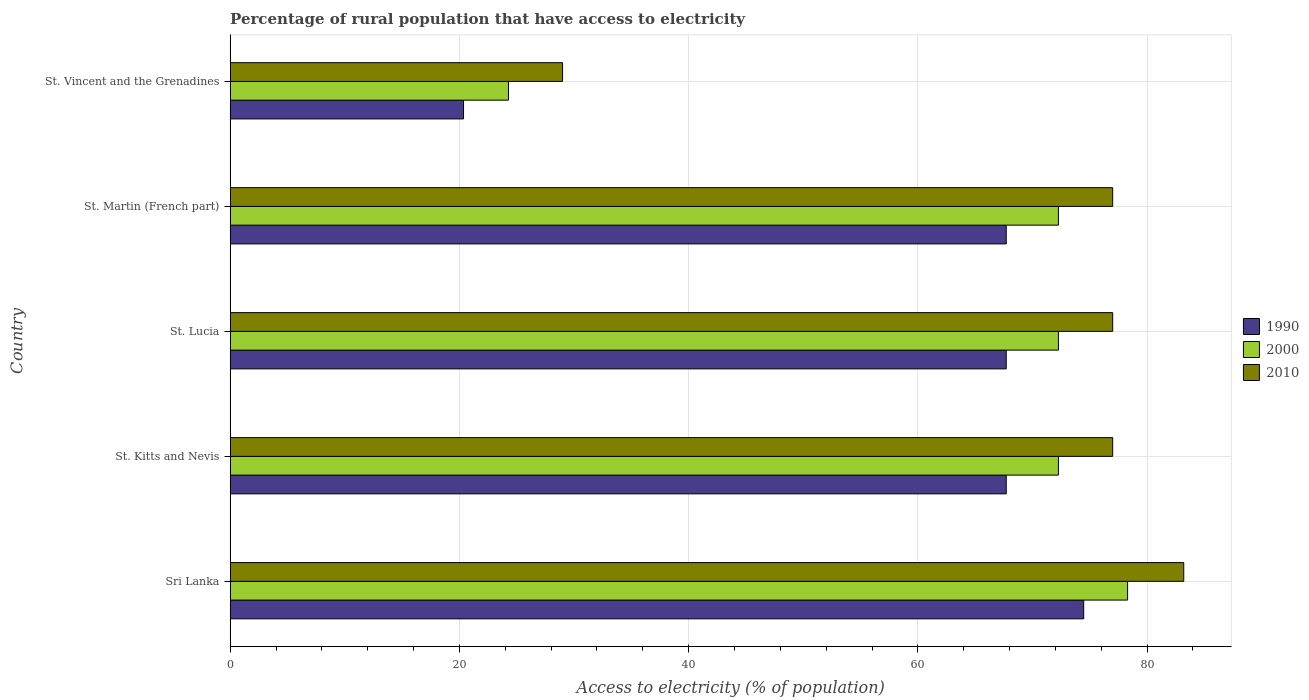How many different coloured bars are there?
Your response must be concise. 3. Are the number of bars on each tick of the Y-axis equal?
Ensure brevity in your answer.  Yes. How many bars are there on the 4th tick from the top?
Offer a very short reply. 3. How many bars are there on the 4th tick from the bottom?
Give a very brief answer. 3. What is the label of the 3rd group of bars from the top?
Your response must be concise. St. Lucia. In how many cases, is the number of bars for a given country not equal to the number of legend labels?
Provide a short and direct response. 0. What is the percentage of rural population that have access to electricity in 1990 in Sri Lanka?
Your answer should be compact. 74.47. Across all countries, what is the maximum percentage of rural population that have access to electricity in 1990?
Give a very brief answer. 74.47. Across all countries, what is the minimum percentage of rural population that have access to electricity in 2010?
Make the answer very short. 29. In which country was the percentage of rural population that have access to electricity in 2000 maximum?
Ensure brevity in your answer.  Sri Lanka. In which country was the percentage of rural population that have access to electricity in 2000 minimum?
Your response must be concise. St. Vincent and the Grenadines. What is the total percentage of rural population that have access to electricity in 1990 in the graph?
Your answer should be compact. 297.96. What is the difference between the percentage of rural population that have access to electricity in 2000 in St. Martin (French part) and the percentage of rural population that have access to electricity in 2010 in St. Kitts and Nevis?
Your answer should be very brief. -4.73. What is the average percentage of rural population that have access to electricity in 2000 per country?
Offer a very short reply. 63.88. What is the difference between the percentage of rural population that have access to electricity in 2010 and percentage of rural population that have access to electricity in 1990 in St. Lucia?
Your answer should be compact. 9.29. What is the ratio of the percentage of rural population that have access to electricity in 1990 in St. Lucia to that in St. Vincent and the Grenadines?
Give a very brief answer. 3.33. Is the percentage of rural population that have access to electricity in 1990 in St. Martin (French part) less than that in St. Vincent and the Grenadines?
Offer a very short reply. No. What is the difference between the highest and the second highest percentage of rural population that have access to electricity in 2010?
Make the answer very short. 6.2. What is the difference between the highest and the lowest percentage of rural population that have access to electricity in 2000?
Provide a short and direct response. 54.02. In how many countries, is the percentage of rural population that have access to electricity in 2000 greater than the average percentage of rural population that have access to electricity in 2000 taken over all countries?
Provide a succinct answer. 4. What does the 1st bar from the bottom in St. Vincent and the Grenadines represents?
Provide a short and direct response. 1990. Is it the case that in every country, the sum of the percentage of rural population that have access to electricity in 1990 and percentage of rural population that have access to electricity in 2000 is greater than the percentage of rural population that have access to electricity in 2010?
Offer a very short reply. Yes. How many bars are there?
Keep it short and to the point. 15. Are all the bars in the graph horizontal?
Provide a short and direct response. Yes. Are the values on the major ticks of X-axis written in scientific E-notation?
Your answer should be compact. No. Does the graph contain any zero values?
Ensure brevity in your answer.  No. Where does the legend appear in the graph?
Offer a very short reply. Center right. How are the legend labels stacked?
Offer a terse response. Vertical. What is the title of the graph?
Your answer should be compact. Percentage of rural population that have access to electricity. Does "1968" appear as one of the legend labels in the graph?
Offer a very short reply. No. What is the label or title of the X-axis?
Provide a succinct answer. Access to electricity (% of population). What is the label or title of the Y-axis?
Your response must be concise. Country. What is the Access to electricity (% of population) of 1990 in Sri Lanka?
Your response must be concise. 74.47. What is the Access to electricity (% of population) of 2000 in Sri Lanka?
Keep it short and to the point. 78.3. What is the Access to electricity (% of population) of 2010 in Sri Lanka?
Your answer should be very brief. 83.2. What is the Access to electricity (% of population) of 1990 in St. Kitts and Nevis?
Ensure brevity in your answer.  67.71. What is the Access to electricity (% of population) in 2000 in St. Kitts and Nevis?
Keep it short and to the point. 72.27. What is the Access to electricity (% of population) in 1990 in St. Lucia?
Your answer should be compact. 67.71. What is the Access to electricity (% of population) of 2000 in St. Lucia?
Offer a very short reply. 72.27. What is the Access to electricity (% of population) of 1990 in St. Martin (French part)?
Offer a very short reply. 67.71. What is the Access to electricity (% of population) in 2000 in St. Martin (French part)?
Make the answer very short. 72.27. What is the Access to electricity (% of population) in 1990 in St. Vincent and the Grenadines?
Your response must be concise. 20.36. What is the Access to electricity (% of population) of 2000 in St. Vincent and the Grenadines?
Your answer should be very brief. 24.28. Across all countries, what is the maximum Access to electricity (% of population) of 1990?
Give a very brief answer. 74.47. Across all countries, what is the maximum Access to electricity (% of population) in 2000?
Your answer should be compact. 78.3. Across all countries, what is the maximum Access to electricity (% of population) in 2010?
Ensure brevity in your answer.  83.2. Across all countries, what is the minimum Access to electricity (% of population) in 1990?
Provide a succinct answer. 20.36. Across all countries, what is the minimum Access to electricity (% of population) in 2000?
Make the answer very short. 24.28. What is the total Access to electricity (% of population) of 1990 in the graph?
Make the answer very short. 297.96. What is the total Access to electricity (% of population) in 2000 in the graph?
Ensure brevity in your answer.  319.38. What is the total Access to electricity (% of population) in 2010 in the graph?
Your response must be concise. 343.2. What is the difference between the Access to electricity (% of population) in 1990 in Sri Lanka and that in St. Kitts and Nevis?
Your answer should be compact. 6.76. What is the difference between the Access to electricity (% of population) in 2000 in Sri Lanka and that in St. Kitts and Nevis?
Provide a short and direct response. 6.04. What is the difference between the Access to electricity (% of population) in 1990 in Sri Lanka and that in St. Lucia?
Provide a short and direct response. 6.76. What is the difference between the Access to electricity (% of population) of 2000 in Sri Lanka and that in St. Lucia?
Provide a short and direct response. 6.04. What is the difference between the Access to electricity (% of population) of 1990 in Sri Lanka and that in St. Martin (French part)?
Make the answer very short. 6.76. What is the difference between the Access to electricity (% of population) in 2000 in Sri Lanka and that in St. Martin (French part)?
Your answer should be compact. 6.04. What is the difference between the Access to electricity (% of population) of 2010 in Sri Lanka and that in St. Martin (French part)?
Keep it short and to the point. 6.2. What is the difference between the Access to electricity (% of population) of 1990 in Sri Lanka and that in St. Vincent and the Grenadines?
Give a very brief answer. 54.11. What is the difference between the Access to electricity (% of population) in 2000 in Sri Lanka and that in St. Vincent and the Grenadines?
Give a very brief answer. 54.02. What is the difference between the Access to electricity (% of population) in 2010 in Sri Lanka and that in St. Vincent and the Grenadines?
Provide a short and direct response. 54.2. What is the difference between the Access to electricity (% of population) of 2000 in St. Kitts and Nevis and that in St. Lucia?
Your answer should be very brief. 0. What is the difference between the Access to electricity (% of population) of 1990 in St. Kitts and Nevis and that in St. Martin (French part)?
Make the answer very short. 0. What is the difference between the Access to electricity (% of population) of 2010 in St. Kitts and Nevis and that in St. Martin (French part)?
Offer a very short reply. 0. What is the difference between the Access to electricity (% of population) in 1990 in St. Kitts and Nevis and that in St. Vincent and the Grenadines?
Make the answer very short. 47.35. What is the difference between the Access to electricity (% of population) of 2000 in St. Kitts and Nevis and that in St. Vincent and the Grenadines?
Ensure brevity in your answer.  47.98. What is the difference between the Access to electricity (% of population) in 2000 in St. Lucia and that in St. Martin (French part)?
Provide a succinct answer. 0. What is the difference between the Access to electricity (% of population) of 2010 in St. Lucia and that in St. Martin (French part)?
Keep it short and to the point. 0. What is the difference between the Access to electricity (% of population) in 1990 in St. Lucia and that in St. Vincent and the Grenadines?
Ensure brevity in your answer.  47.35. What is the difference between the Access to electricity (% of population) of 2000 in St. Lucia and that in St. Vincent and the Grenadines?
Give a very brief answer. 47.98. What is the difference between the Access to electricity (% of population) of 1990 in St. Martin (French part) and that in St. Vincent and the Grenadines?
Give a very brief answer. 47.35. What is the difference between the Access to electricity (% of population) in 2000 in St. Martin (French part) and that in St. Vincent and the Grenadines?
Your answer should be very brief. 47.98. What is the difference between the Access to electricity (% of population) in 1990 in Sri Lanka and the Access to electricity (% of population) in 2000 in St. Kitts and Nevis?
Offer a very short reply. 2.2. What is the difference between the Access to electricity (% of population) in 1990 in Sri Lanka and the Access to electricity (% of population) in 2010 in St. Kitts and Nevis?
Your response must be concise. -2.53. What is the difference between the Access to electricity (% of population) in 2000 in Sri Lanka and the Access to electricity (% of population) in 2010 in St. Kitts and Nevis?
Your answer should be compact. 1.3. What is the difference between the Access to electricity (% of population) of 1990 in Sri Lanka and the Access to electricity (% of population) of 2000 in St. Lucia?
Provide a succinct answer. 2.2. What is the difference between the Access to electricity (% of population) of 1990 in Sri Lanka and the Access to electricity (% of population) of 2010 in St. Lucia?
Your response must be concise. -2.53. What is the difference between the Access to electricity (% of population) in 2000 in Sri Lanka and the Access to electricity (% of population) in 2010 in St. Lucia?
Offer a terse response. 1.3. What is the difference between the Access to electricity (% of population) in 1990 in Sri Lanka and the Access to electricity (% of population) in 2000 in St. Martin (French part)?
Give a very brief answer. 2.2. What is the difference between the Access to electricity (% of population) of 1990 in Sri Lanka and the Access to electricity (% of population) of 2010 in St. Martin (French part)?
Your response must be concise. -2.53. What is the difference between the Access to electricity (% of population) in 1990 in Sri Lanka and the Access to electricity (% of population) in 2000 in St. Vincent and the Grenadines?
Make the answer very short. 50.19. What is the difference between the Access to electricity (% of population) of 1990 in Sri Lanka and the Access to electricity (% of population) of 2010 in St. Vincent and the Grenadines?
Your answer should be compact. 45.47. What is the difference between the Access to electricity (% of population) in 2000 in Sri Lanka and the Access to electricity (% of population) in 2010 in St. Vincent and the Grenadines?
Offer a very short reply. 49.3. What is the difference between the Access to electricity (% of population) in 1990 in St. Kitts and Nevis and the Access to electricity (% of population) in 2000 in St. Lucia?
Your answer should be compact. -4.55. What is the difference between the Access to electricity (% of population) of 1990 in St. Kitts and Nevis and the Access to electricity (% of population) of 2010 in St. Lucia?
Provide a short and direct response. -9.29. What is the difference between the Access to electricity (% of population) of 2000 in St. Kitts and Nevis and the Access to electricity (% of population) of 2010 in St. Lucia?
Provide a succinct answer. -4.74. What is the difference between the Access to electricity (% of population) of 1990 in St. Kitts and Nevis and the Access to electricity (% of population) of 2000 in St. Martin (French part)?
Provide a short and direct response. -4.55. What is the difference between the Access to electricity (% of population) in 1990 in St. Kitts and Nevis and the Access to electricity (% of population) in 2010 in St. Martin (French part)?
Give a very brief answer. -9.29. What is the difference between the Access to electricity (% of population) in 2000 in St. Kitts and Nevis and the Access to electricity (% of population) in 2010 in St. Martin (French part)?
Make the answer very short. -4.74. What is the difference between the Access to electricity (% of population) of 1990 in St. Kitts and Nevis and the Access to electricity (% of population) of 2000 in St. Vincent and the Grenadines?
Your response must be concise. 43.43. What is the difference between the Access to electricity (% of population) in 1990 in St. Kitts and Nevis and the Access to electricity (% of population) in 2010 in St. Vincent and the Grenadines?
Provide a succinct answer. 38.71. What is the difference between the Access to electricity (% of population) of 2000 in St. Kitts and Nevis and the Access to electricity (% of population) of 2010 in St. Vincent and the Grenadines?
Your answer should be very brief. 43.27. What is the difference between the Access to electricity (% of population) in 1990 in St. Lucia and the Access to electricity (% of population) in 2000 in St. Martin (French part)?
Keep it short and to the point. -4.55. What is the difference between the Access to electricity (% of population) of 1990 in St. Lucia and the Access to electricity (% of population) of 2010 in St. Martin (French part)?
Make the answer very short. -9.29. What is the difference between the Access to electricity (% of population) in 2000 in St. Lucia and the Access to electricity (% of population) in 2010 in St. Martin (French part)?
Your response must be concise. -4.74. What is the difference between the Access to electricity (% of population) in 1990 in St. Lucia and the Access to electricity (% of population) in 2000 in St. Vincent and the Grenadines?
Your response must be concise. 43.43. What is the difference between the Access to electricity (% of population) in 1990 in St. Lucia and the Access to electricity (% of population) in 2010 in St. Vincent and the Grenadines?
Ensure brevity in your answer.  38.71. What is the difference between the Access to electricity (% of population) in 2000 in St. Lucia and the Access to electricity (% of population) in 2010 in St. Vincent and the Grenadines?
Give a very brief answer. 43.27. What is the difference between the Access to electricity (% of population) in 1990 in St. Martin (French part) and the Access to electricity (% of population) in 2000 in St. Vincent and the Grenadines?
Your answer should be compact. 43.43. What is the difference between the Access to electricity (% of population) in 1990 in St. Martin (French part) and the Access to electricity (% of population) in 2010 in St. Vincent and the Grenadines?
Ensure brevity in your answer.  38.71. What is the difference between the Access to electricity (% of population) of 2000 in St. Martin (French part) and the Access to electricity (% of population) of 2010 in St. Vincent and the Grenadines?
Provide a succinct answer. 43.27. What is the average Access to electricity (% of population) of 1990 per country?
Keep it short and to the point. 59.59. What is the average Access to electricity (% of population) in 2000 per country?
Make the answer very short. 63.88. What is the average Access to electricity (% of population) of 2010 per country?
Your answer should be compact. 68.64. What is the difference between the Access to electricity (% of population) of 1990 and Access to electricity (% of population) of 2000 in Sri Lanka?
Ensure brevity in your answer.  -3.83. What is the difference between the Access to electricity (% of population) in 1990 and Access to electricity (% of population) in 2010 in Sri Lanka?
Keep it short and to the point. -8.73. What is the difference between the Access to electricity (% of population) of 2000 and Access to electricity (% of population) of 2010 in Sri Lanka?
Offer a terse response. -4.9. What is the difference between the Access to electricity (% of population) of 1990 and Access to electricity (% of population) of 2000 in St. Kitts and Nevis?
Offer a terse response. -4.55. What is the difference between the Access to electricity (% of population) in 1990 and Access to electricity (% of population) in 2010 in St. Kitts and Nevis?
Ensure brevity in your answer.  -9.29. What is the difference between the Access to electricity (% of population) of 2000 and Access to electricity (% of population) of 2010 in St. Kitts and Nevis?
Your response must be concise. -4.74. What is the difference between the Access to electricity (% of population) of 1990 and Access to electricity (% of population) of 2000 in St. Lucia?
Your response must be concise. -4.55. What is the difference between the Access to electricity (% of population) in 1990 and Access to electricity (% of population) in 2010 in St. Lucia?
Give a very brief answer. -9.29. What is the difference between the Access to electricity (% of population) of 2000 and Access to electricity (% of population) of 2010 in St. Lucia?
Offer a terse response. -4.74. What is the difference between the Access to electricity (% of population) of 1990 and Access to electricity (% of population) of 2000 in St. Martin (French part)?
Offer a terse response. -4.55. What is the difference between the Access to electricity (% of population) in 1990 and Access to electricity (% of population) in 2010 in St. Martin (French part)?
Give a very brief answer. -9.29. What is the difference between the Access to electricity (% of population) of 2000 and Access to electricity (% of population) of 2010 in St. Martin (French part)?
Your response must be concise. -4.74. What is the difference between the Access to electricity (% of population) of 1990 and Access to electricity (% of population) of 2000 in St. Vincent and the Grenadines?
Give a very brief answer. -3.92. What is the difference between the Access to electricity (% of population) of 1990 and Access to electricity (% of population) of 2010 in St. Vincent and the Grenadines?
Provide a succinct answer. -8.64. What is the difference between the Access to electricity (% of population) in 2000 and Access to electricity (% of population) in 2010 in St. Vincent and the Grenadines?
Offer a very short reply. -4.72. What is the ratio of the Access to electricity (% of population) in 1990 in Sri Lanka to that in St. Kitts and Nevis?
Your answer should be compact. 1.1. What is the ratio of the Access to electricity (% of population) of 2000 in Sri Lanka to that in St. Kitts and Nevis?
Offer a terse response. 1.08. What is the ratio of the Access to electricity (% of population) in 2010 in Sri Lanka to that in St. Kitts and Nevis?
Give a very brief answer. 1.08. What is the ratio of the Access to electricity (% of population) of 1990 in Sri Lanka to that in St. Lucia?
Make the answer very short. 1.1. What is the ratio of the Access to electricity (% of population) of 2000 in Sri Lanka to that in St. Lucia?
Give a very brief answer. 1.08. What is the ratio of the Access to electricity (% of population) of 2010 in Sri Lanka to that in St. Lucia?
Give a very brief answer. 1.08. What is the ratio of the Access to electricity (% of population) in 1990 in Sri Lanka to that in St. Martin (French part)?
Keep it short and to the point. 1.1. What is the ratio of the Access to electricity (% of population) in 2000 in Sri Lanka to that in St. Martin (French part)?
Offer a terse response. 1.08. What is the ratio of the Access to electricity (% of population) in 2010 in Sri Lanka to that in St. Martin (French part)?
Offer a very short reply. 1.08. What is the ratio of the Access to electricity (% of population) of 1990 in Sri Lanka to that in St. Vincent and the Grenadines?
Offer a very short reply. 3.66. What is the ratio of the Access to electricity (% of population) of 2000 in Sri Lanka to that in St. Vincent and the Grenadines?
Your answer should be very brief. 3.22. What is the ratio of the Access to electricity (% of population) in 2010 in Sri Lanka to that in St. Vincent and the Grenadines?
Your answer should be compact. 2.87. What is the ratio of the Access to electricity (% of population) in 1990 in St. Kitts and Nevis to that in St. Lucia?
Provide a short and direct response. 1. What is the ratio of the Access to electricity (% of population) of 2010 in St. Kitts and Nevis to that in St. Lucia?
Ensure brevity in your answer.  1. What is the ratio of the Access to electricity (% of population) of 1990 in St. Kitts and Nevis to that in St. Martin (French part)?
Offer a terse response. 1. What is the ratio of the Access to electricity (% of population) of 2000 in St. Kitts and Nevis to that in St. Martin (French part)?
Keep it short and to the point. 1. What is the ratio of the Access to electricity (% of population) in 1990 in St. Kitts and Nevis to that in St. Vincent and the Grenadines?
Provide a succinct answer. 3.33. What is the ratio of the Access to electricity (% of population) of 2000 in St. Kitts and Nevis to that in St. Vincent and the Grenadines?
Your answer should be very brief. 2.98. What is the ratio of the Access to electricity (% of population) of 2010 in St. Kitts and Nevis to that in St. Vincent and the Grenadines?
Provide a short and direct response. 2.66. What is the ratio of the Access to electricity (% of population) in 1990 in St. Lucia to that in St. Martin (French part)?
Keep it short and to the point. 1. What is the ratio of the Access to electricity (% of population) in 2010 in St. Lucia to that in St. Martin (French part)?
Offer a terse response. 1. What is the ratio of the Access to electricity (% of population) of 1990 in St. Lucia to that in St. Vincent and the Grenadines?
Make the answer very short. 3.33. What is the ratio of the Access to electricity (% of population) in 2000 in St. Lucia to that in St. Vincent and the Grenadines?
Give a very brief answer. 2.98. What is the ratio of the Access to electricity (% of population) of 2010 in St. Lucia to that in St. Vincent and the Grenadines?
Give a very brief answer. 2.66. What is the ratio of the Access to electricity (% of population) in 1990 in St. Martin (French part) to that in St. Vincent and the Grenadines?
Make the answer very short. 3.33. What is the ratio of the Access to electricity (% of population) of 2000 in St. Martin (French part) to that in St. Vincent and the Grenadines?
Offer a terse response. 2.98. What is the ratio of the Access to electricity (% of population) in 2010 in St. Martin (French part) to that in St. Vincent and the Grenadines?
Provide a short and direct response. 2.66. What is the difference between the highest and the second highest Access to electricity (% of population) of 1990?
Offer a very short reply. 6.76. What is the difference between the highest and the second highest Access to electricity (% of population) in 2000?
Your answer should be compact. 6.04. What is the difference between the highest and the second highest Access to electricity (% of population) in 2010?
Offer a very short reply. 6.2. What is the difference between the highest and the lowest Access to electricity (% of population) in 1990?
Keep it short and to the point. 54.11. What is the difference between the highest and the lowest Access to electricity (% of population) in 2000?
Keep it short and to the point. 54.02. What is the difference between the highest and the lowest Access to electricity (% of population) in 2010?
Your response must be concise. 54.2. 